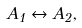Convert formula to latex. <formula><loc_0><loc_0><loc_500><loc_500>A _ { 1 } \leftrightarrow A _ { 2 } ,</formula> 